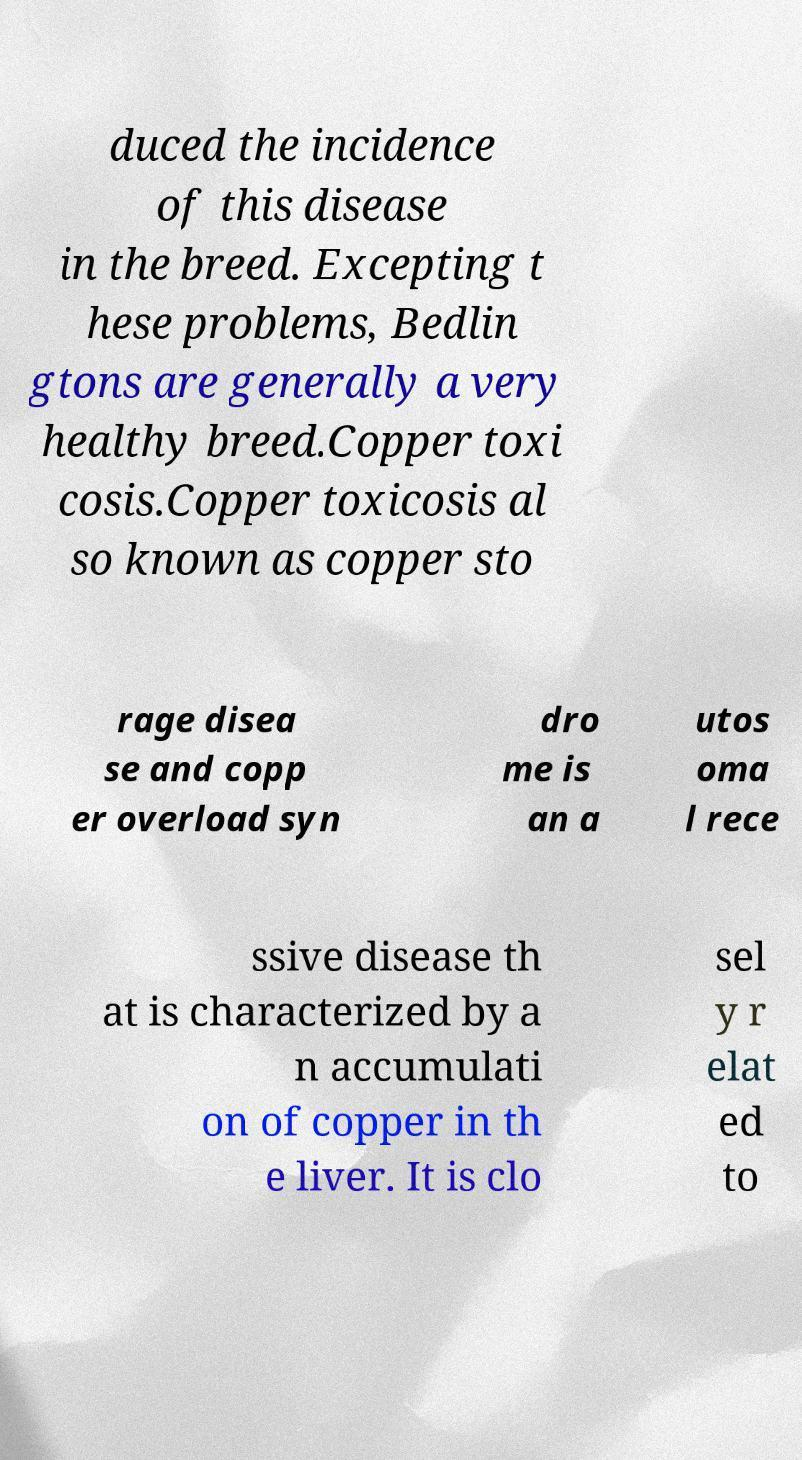I need the written content from this picture converted into text. Can you do that? duced the incidence of this disease in the breed. Excepting t hese problems, Bedlin gtons are generally a very healthy breed.Copper toxi cosis.Copper toxicosis al so known as copper sto rage disea se and copp er overload syn dro me is an a utos oma l rece ssive disease th at is characterized by a n accumulati on of copper in th e liver. It is clo sel y r elat ed to 